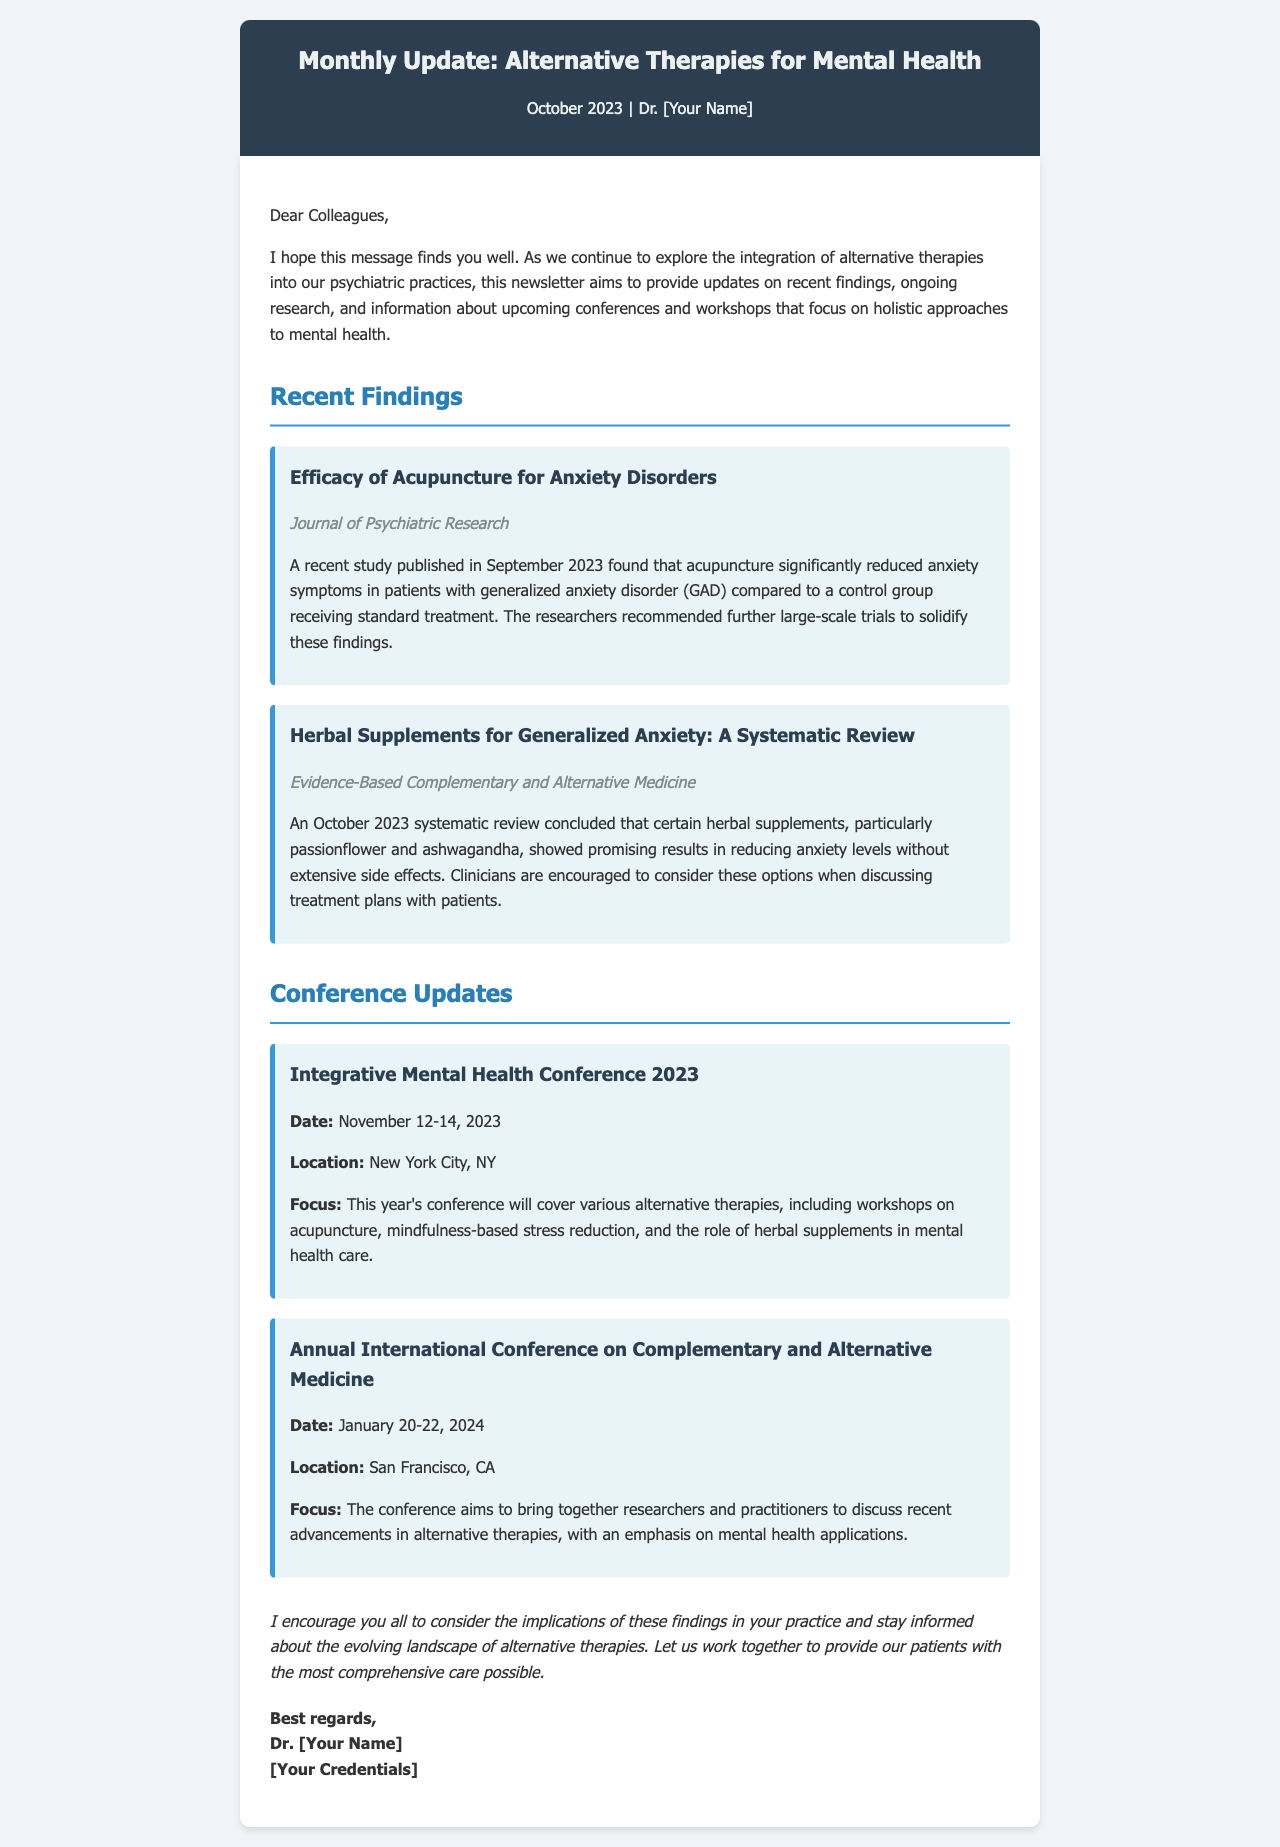What is the title of the newsletter? The title of the newsletter is mentioned in the header section of the document.
Answer: Monthly Update: Alternative Therapies for Mental Health What is the date of the "Integrative Mental Health Conference 2023"? The date is provided in the conference updates section of the document.
Answer: November 12-14, 2023 Which herbal supplements are mentioned in the systematic review? The document specifies the herbal supplements discussed in the review section.
Answer: Passionflower and ashwagandha What is the source of the study on acupuncture for anxiety disorders? The source is noted at the end of the acupuncture study section.
Answer: Journal of Psychiatric Research What is the location of the "Annual International Conference on Complementary and Alternative Medicine"? The location is provided in the conference updates section of the document.
Answer: San Francisco, CA How does the document categorize the recent findings? This indicates how the document is structured regarding the content it covers.
Answer: Recent Findings Why is it important to stay informed about alternative therapies according to the conclusion? The conclusion summarizes the document's purpose in encouraging further consideration of findings.
Answer: Comprehensive care 